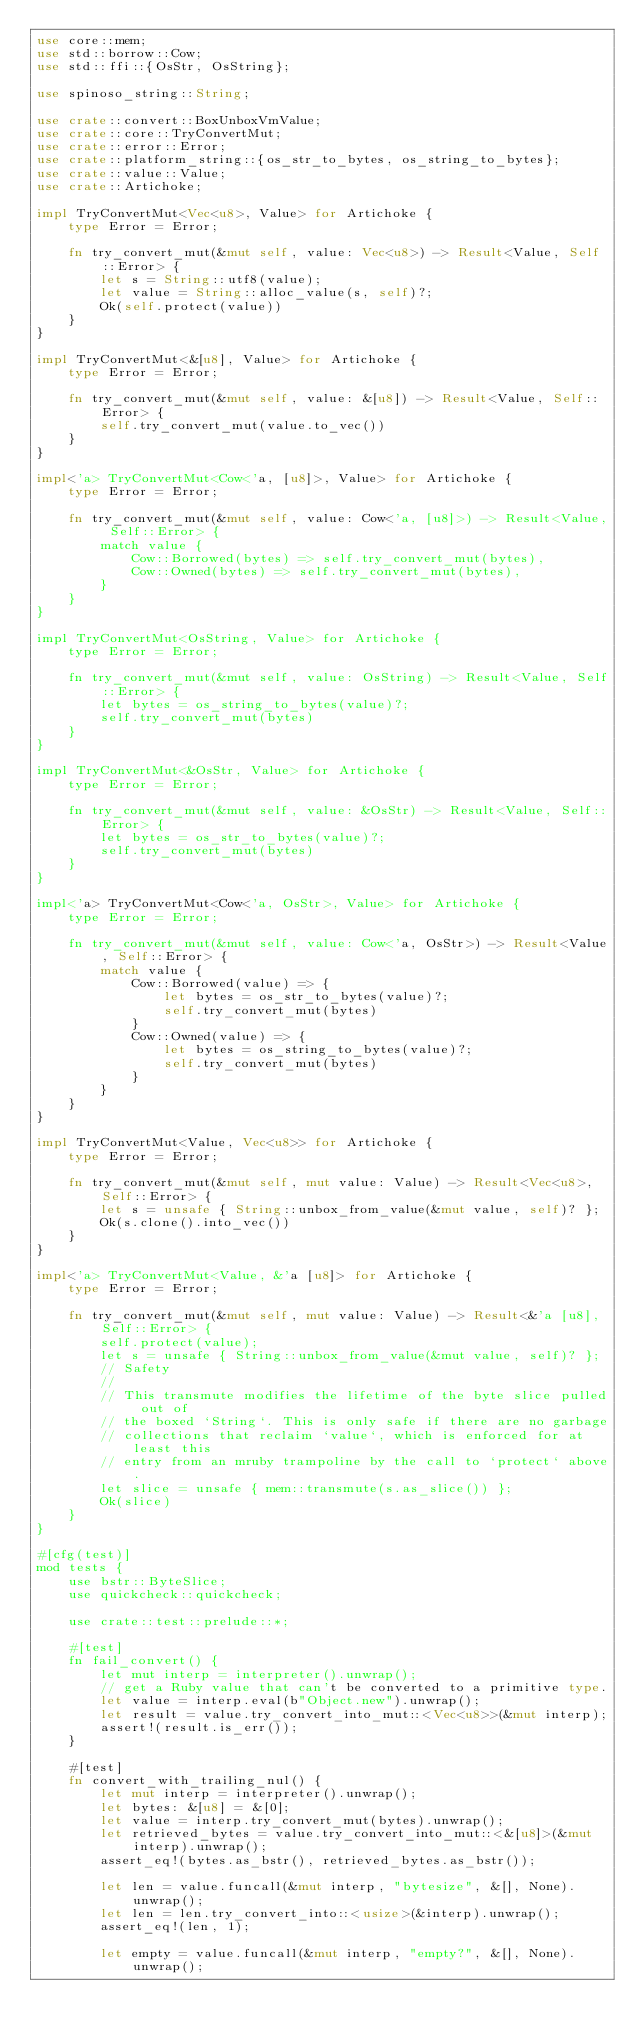Convert code to text. <code><loc_0><loc_0><loc_500><loc_500><_Rust_>use core::mem;
use std::borrow::Cow;
use std::ffi::{OsStr, OsString};

use spinoso_string::String;

use crate::convert::BoxUnboxVmValue;
use crate::core::TryConvertMut;
use crate::error::Error;
use crate::platform_string::{os_str_to_bytes, os_string_to_bytes};
use crate::value::Value;
use crate::Artichoke;

impl TryConvertMut<Vec<u8>, Value> for Artichoke {
    type Error = Error;

    fn try_convert_mut(&mut self, value: Vec<u8>) -> Result<Value, Self::Error> {
        let s = String::utf8(value);
        let value = String::alloc_value(s, self)?;
        Ok(self.protect(value))
    }
}

impl TryConvertMut<&[u8], Value> for Artichoke {
    type Error = Error;

    fn try_convert_mut(&mut self, value: &[u8]) -> Result<Value, Self::Error> {
        self.try_convert_mut(value.to_vec())
    }
}

impl<'a> TryConvertMut<Cow<'a, [u8]>, Value> for Artichoke {
    type Error = Error;

    fn try_convert_mut(&mut self, value: Cow<'a, [u8]>) -> Result<Value, Self::Error> {
        match value {
            Cow::Borrowed(bytes) => self.try_convert_mut(bytes),
            Cow::Owned(bytes) => self.try_convert_mut(bytes),
        }
    }
}

impl TryConvertMut<OsString, Value> for Artichoke {
    type Error = Error;

    fn try_convert_mut(&mut self, value: OsString) -> Result<Value, Self::Error> {
        let bytes = os_string_to_bytes(value)?;
        self.try_convert_mut(bytes)
    }
}

impl TryConvertMut<&OsStr, Value> for Artichoke {
    type Error = Error;

    fn try_convert_mut(&mut self, value: &OsStr) -> Result<Value, Self::Error> {
        let bytes = os_str_to_bytes(value)?;
        self.try_convert_mut(bytes)
    }
}

impl<'a> TryConvertMut<Cow<'a, OsStr>, Value> for Artichoke {
    type Error = Error;

    fn try_convert_mut(&mut self, value: Cow<'a, OsStr>) -> Result<Value, Self::Error> {
        match value {
            Cow::Borrowed(value) => {
                let bytes = os_str_to_bytes(value)?;
                self.try_convert_mut(bytes)
            }
            Cow::Owned(value) => {
                let bytes = os_string_to_bytes(value)?;
                self.try_convert_mut(bytes)
            }
        }
    }
}

impl TryConvertMut<Value, Vec<u8>> for Artichoke {
    type Error = Error;

    fn try_convert_mut(&mut self, mut value: Value) -> Result<Vec<u8>, Self::Error> {
        let s = unsafe { String::unbox_from_value(&mut value, self)? };
        Ok(s.clone().into_vec())
    }
}

impl<'a> TryConvertMut<Value, &'a [u8]> for Artichoke {
    type Error = Error;

    fn try_convert_mut(&mut self, mut value: Value) -> Result<&'a [u8], Self::Error> {
        self.protect(value);
        let s = unsafe { String::unbox_from_value(&mut value, self)? };
        // Safety
        //
        // This transmute modifies the lifetime of the byte slice pulled out of
        // the boxed `String`. This is only safe if there are no garbage
        // collections that reclaim `value`, which is enforced for at least this
        // entry from an mruby trampoline by the call to `protect` above.
        let slice = unsafe { mem::transmute(s.as_slice()) };
        Ok(slice)
    }
}

#[cfg(test)]
mod tests {
    use bstr::ByteSlice;
    use quickcheck::quickcheck;

    use crate::test::prelude::*;

    #[test]
    fn fail_convert() {
        let mut interp = interpreter().unwrap();
        // get a Ruby value that can't be converted to a primitive type.
        let value = interp.eval(b"Object.new").unwrap();
        let result = value.try_convert_into_mut::<Vec<u8>>(&mut interp);
        assert!(result.is_err());
    }

    #[test]
    fn convert_with_trailing_nul() {
        let mut interp = interpreter().unwrap();
        let bytes: &[u8] = &[0];
        let value = interp.try_convert_mut(bytes).unwrap();
        let retrieved_bytes = value.try_convert_into_mut::<&[u8]>(&mut interp).unwrap();
        assert_eq!(bytes.as_bstr(), retrieved_bytes.as_bstr());

        let len = value.funcall(&mut interp, "bytesize", &[], None).unwrap();
        let len = len.try_convert_into::<usize>(&interp).unwrap();
        assert_eq!(len, 1);

        let empty = value.funcall(&mut interp, "empty?", &[], None).unwrap();</code> 